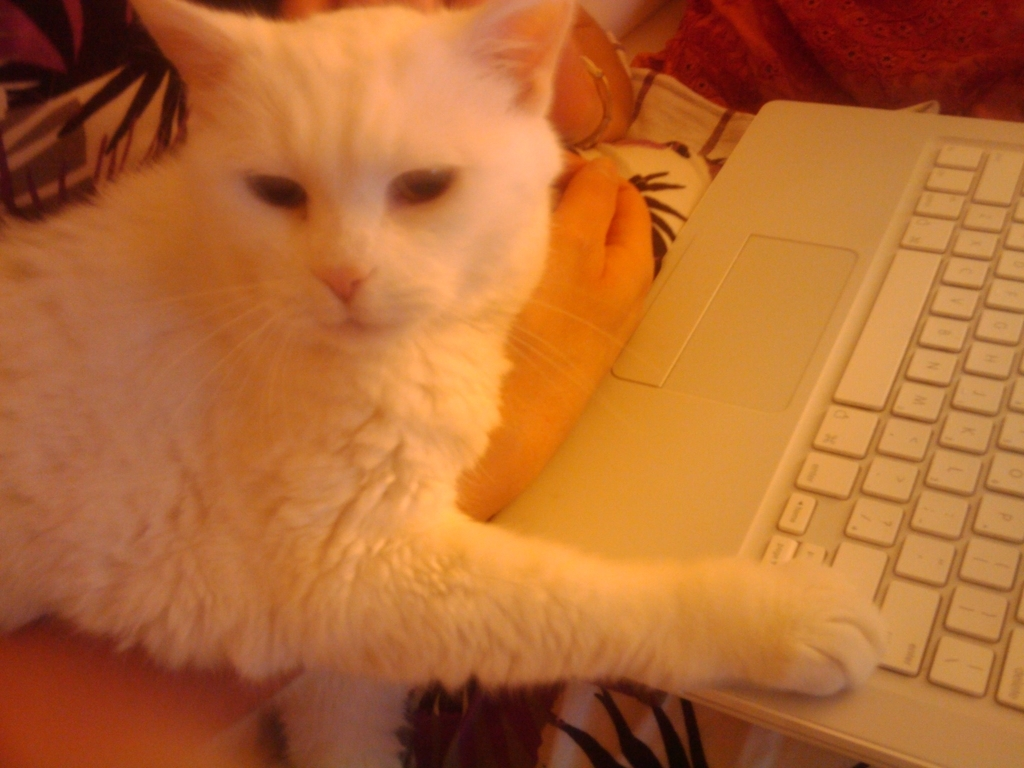What is the lighting condition in the image?
A. Bright
B. Well-lit
C. Ample
D. Insufficient Upon evaluating the image, it appears that the lighting condition can be best described as ample. The subject, which is a white cat, is visible with a moderate amount of light that does not overpower the details of the scene, suggesting the light is neither excessively bright nor insufficient. Therefore, the most accurate choice from the provided options would be 'C. Ample'. 